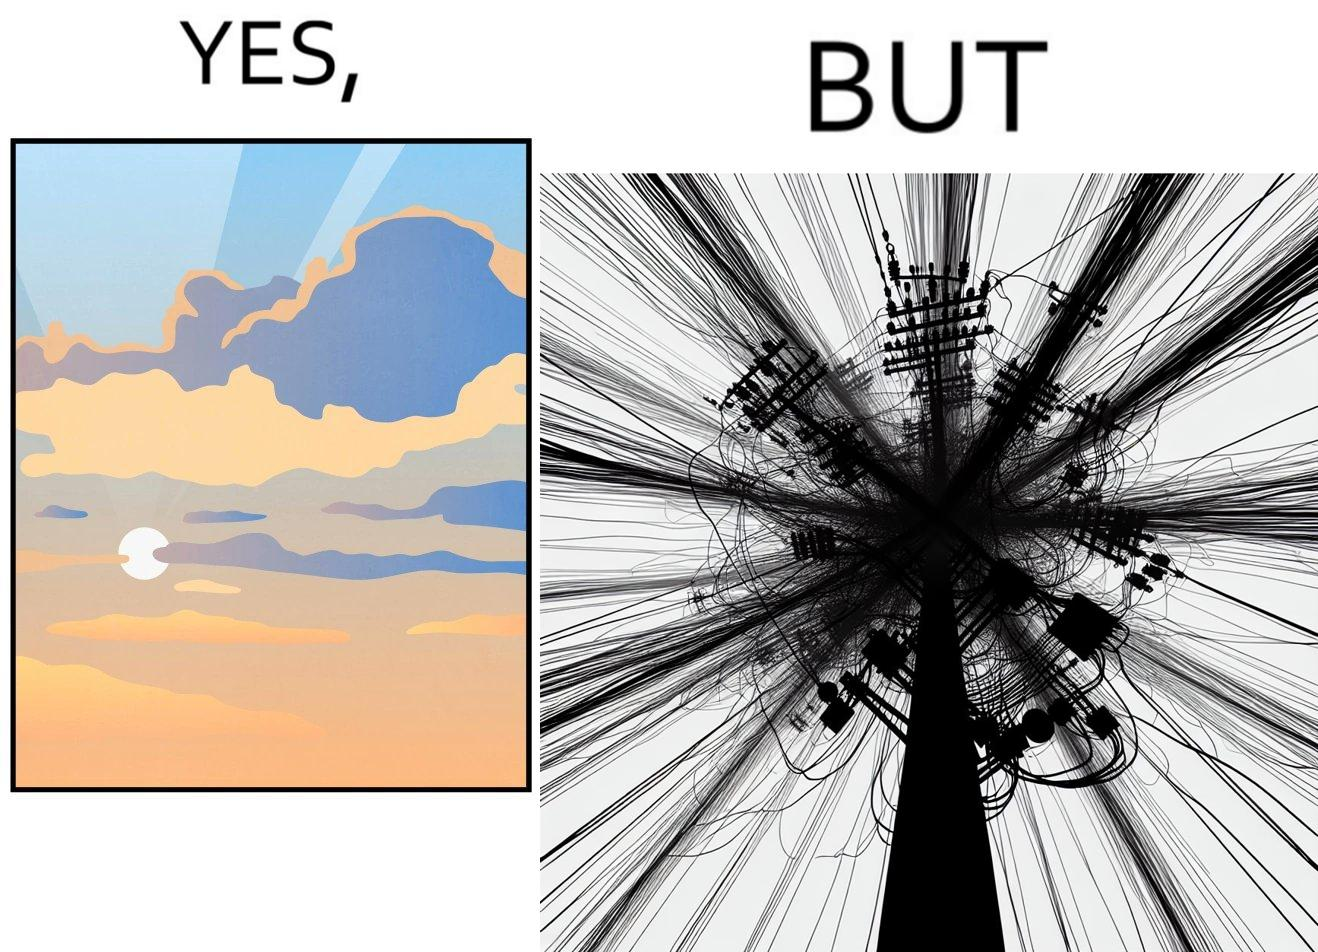What is the satirical meaning behind this image? The image is ironic, because in the first image clear sky is visible but in the second image the same view is getting blocked due to the electricity pole 